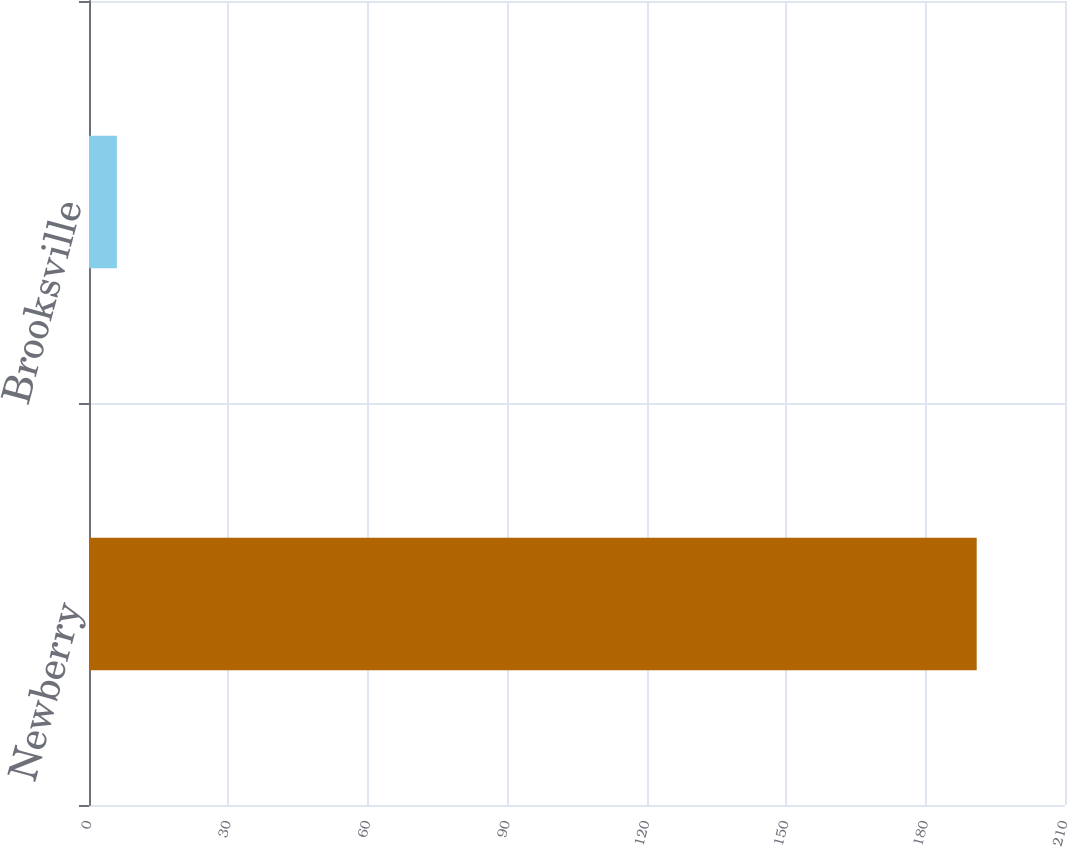Convert chart. <chart><loc_0><loc_0><loc_500><loc_500><bar_chart><fcel>Newberry<fcel>Brooksville<nl><fcel>191<fcel>6<nl></chart> 